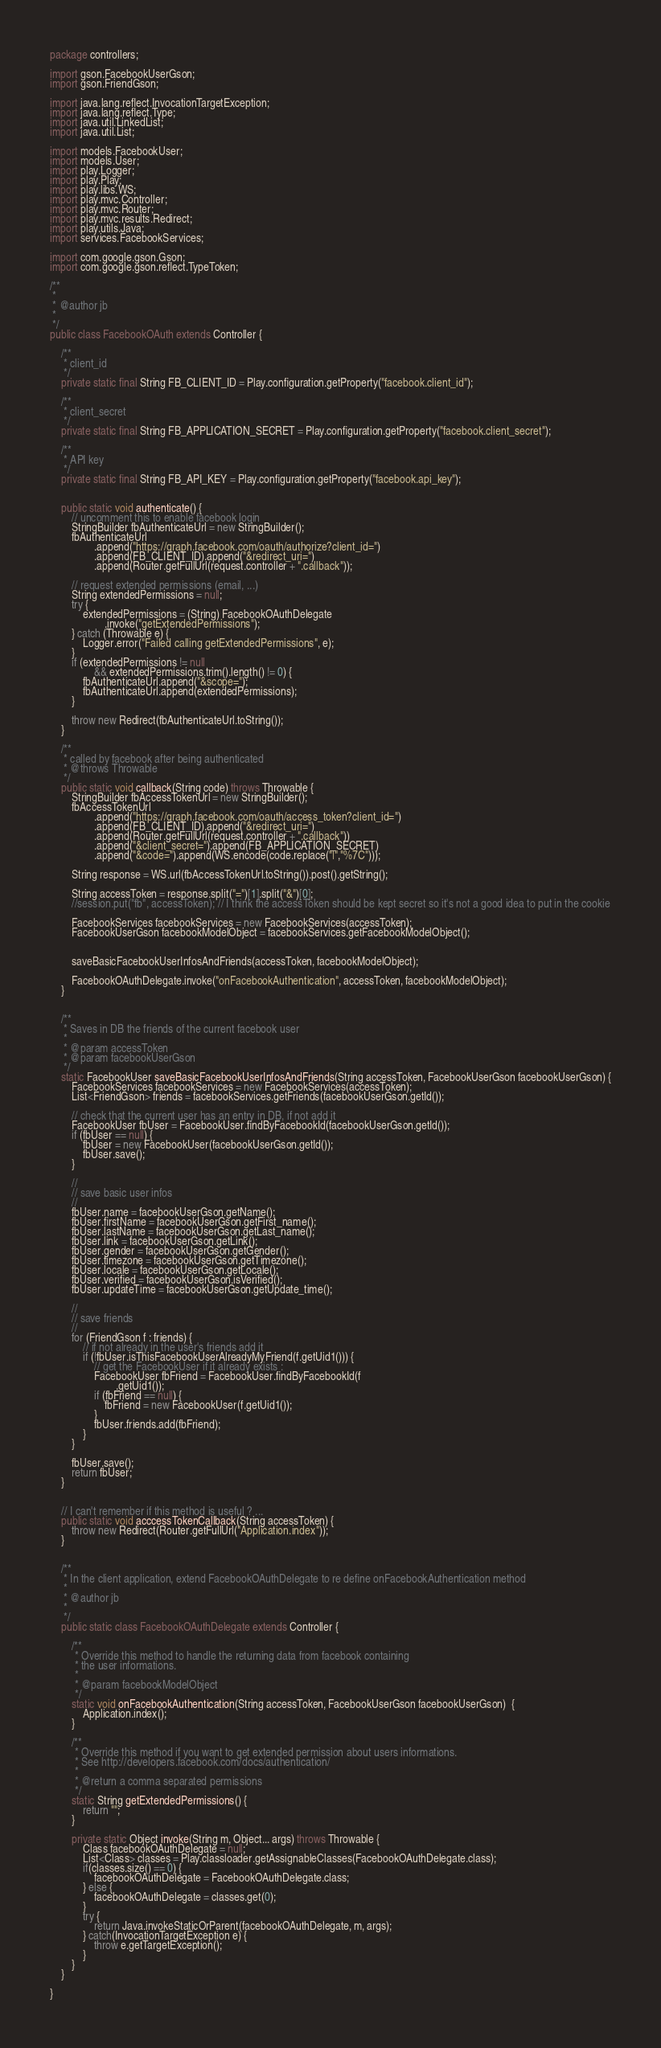Convert code to text. <code><loc_0><loc_0><loc_500><loc_500><_Java_>package controllers;

import gson.FacebookUserGson;
import gson.FriendGson;

import java.lang.reflect.InvocationTargetException;
import java.lang.reflect.Type;
import java.util.LinkedList;
import java.util.List;

import models.FacebookUser;
import models.User;
import play.Logger;
import play.Play;
import play.libs.WS;
import play.mvc.Controller;
import play.mvc.Router;
import play.mvc.results.Redirect;
import play.utils.Java;
import services.FacebookServices;

import com.google.gson.Gson;
import com.google.gson.reflect.TypeToken;

/**
 * 
 * @author jb
 *
 */
public class FacebookOAuth extends Controller {

    /**
     * client_id
     */
    private static final String FB_CLIENT_ID = Play.configuration.getProperty("facebook.client_id"); 
    
    /**
     * client_secret
     */
    private static final String FB_APPLICATION_SECRET = Play.configuration.getProperty("facebook.client_secret");
    
    /**
     * API key
     */
    private static final String FB_API_KEY = Play.configuration.getProperty("facebook.api_key"); 
    
    
    public static void authenticate() {
    	// uncomment this to enable facebook login
		StringBuilder fbAuthenticateUrl = new StringBuilder();
		fbAuthenticateUrl
				.append("https://graph.facebook.com/oauth/authorize?client_id=")
				.append(FB_CLIENT_ID).append("&redirect_uri=")
				.append(Router.getFullUrl(request.controller + ".callback"));
				
		// request extended permissions (email, ...)
		String extendedPermissions = null;
		try {
			extendedPermissions = (String) FacebookOAuthDelegate
					.invoke("getExtendedPermissions");
		} catch (Throwable e) {
			Logger.error("Failed calling getExtendedPermissions", e);
		}
		if (extendedPermissions != null
				&& extendedPermissions.trim().length() != 0) {
			fbAuthenticateUrl.append("&scope=");
			fbAuthenticateUrl.append(extendedPermissions);
		}
		
        throw new Redirect(fbAuthenticateUrl.toString());
    }
    
    /**
     * called by facebook after being authenticated 
     * @throws Throwable 
     */
    public static void callback(String code) throws Throwable {
		StringBuilder fbAccessTokenUrl = new StringBuilder();
		fbAccessTokenUrl
				.append("https://graph.facebook.com/oauth/access_token?client_id=")
				.append(FB_CLIENT_ID).append("&redirect_uri=")
				.append(Router.getFullUrl(request.controller + ".callback"))
				.append("&client_secret=").append(FB_APPLICATION_SECRET)
				.append("&code=").append(WS.encode(code.replace("|","%7C")));
        
        String response = WS.url(fbAccessTokenUrl.toString()).post().getString();
        
        String accessToken = response.split("=")[1].split("&")[0];
        //session.put("fb", accessToken); // I think the accessToken should be kept secret so it's not a good idea to put in the cookie
        
    	FacebookServices facebookServices = new FacebookServices(accessToken);
    	FacebookUserGson facebookModelObject = facebookServices.getFacebookModelObject();
        

    	saveBasicFacebookUserInfosAndFriends(accessToken, facebookModelObject);
    	
        FacebookOAuthDelegate.invoke("onFacebookAuthentication", accessToken, facebookModelObject);
    }
    
    
    /**
     * Saves in DB the friends of the current facebook user 
     * 
     * @param accessToken
     * @param facebookUserGson
     */
    static FacebookUser saveBasicFacebookUserInfosAndFriends(String accessToken, FacebookUserGson facebookUserGson) {
    	FacebookServices facebookServices = new FacebookServices(accessToken);
    	List<FriendGson> friends = facebookServices.getFriends(facebookUserGson.getId());
		
    	// check that the current user has an entry in DB, if not add it
		FacebookUser fbUser = FacebookUser.findByFacebookId(facebookUserGson.getId());
		if (fbUser == null) {
			fbUser = new FacebookUser(facebookUserGson.getId());
			fbUser.save();
		}

		//
		// save basic user infos
		//
		fbUser.name = facebookUserGson.getName();
		fbUser.firstName = facebookUserGson.getFirst_name();
		fbUser.lastName = facebookUserGson.getLast_name();
		fbUser.link = facebookUserGson.getLink();
		fbUser.gender = facebookUserGson.getGender();
		fbUser.timezone = facebookUserGson.getTimezone();
		fbUser.locale = facebookUserGson.getLocale();
		fbUser.verified = facebookUserGson.isVerified();
		fbUser.updateTime = facebookUserGson.getUpdate_time();
		
		//
		// save friends
		//
		for (FriendGson f : friends) {
			// if not already in the user's friends add it
			if (!fbUser.isThisFacebookUserAlreadyMyFriend(f.getUid1())) {
				// get the FacebookUser if it already exists :
				FacebookUser fbFriend = FacebookUser.findByFacebookId(f
						.getUid1());
				if (fbFriend == null) {
					fbFriend = new FacebookUser(f.getUid1());
				}
				fbUser.friends.add(fbFriend);
			}
		}
		
		fbUser.save();
		return fbUser;
    }
    
     
    // I can't remember if this method is useful ? ...
    public static void acccessTokenCallback(String accessToken) {
        throw new Redirect(Router.getFullUrl("Application.index"));
    }

    
    /**
     * In the client application, extend FacebookOAuthDelegate to re define onFacebookAuthentication method
     * 
     * @author jb
     *
     */
    public static class FacebookOAuthDelegate extends Controller {
        
    	/**
    	 * Override this method to handle the returning data from facebook containing
    	 * the user informations.
    	 * 
    	 * @param facebookModelObject
    	 */
        static void onFacebookAuthentication(String accessToken, FacebookUserGson facebookUserGson)  {
            Application.index();
        }
        
        /**
         * Override this method if you want to get extended permission about users informations.
         * See http://developers.facebook.com/docs/authentication/
         * 
         * @return a comma separated permissions
         */
        static String getExtendedPermissions() {
        	return "";
        }
        
        private static Object invoke(String m, Object... args) throws Throwable {
            Class facebookOAuthDelegate = null;
            List<Class> classes = Play.classloader.getAssignableClasses(FacebookOAuthDelegate.class);
            if(classes.size() == 0) {
                facebookOAuthDelegate = FacebookOAuthDelegate.class;
            } else {
                facebookOAuthDelegate = classes.get(0);
            }
            try {
                return Java.invokeStaticOrParent(facebookOAuthDelegate, m, args);
            } catch(InvocationTargetException e) {
                throw e.getTargetException();
            }
        }
    }
    
}
</code> 